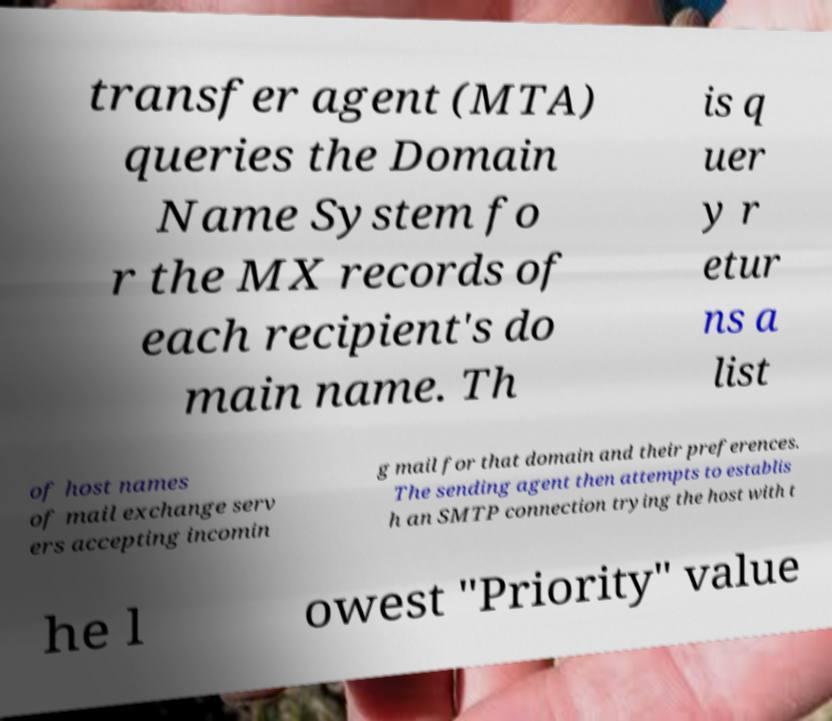What messages or text are displayed in this image? I need them in a readable, typed format. transfer agent (MTA) queries the Domain Name System fo r the MX records of each recipient's do main name. Th is q uer y r etur ns a list of host names of mail exchange serv ers accepting incomin g mail for that domain and their preferences. The sending agent then attempts to establis h an SMTP connection trying the host with t he l owest "Priority" value 